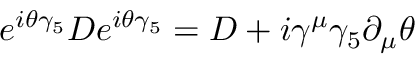Convert formula to latex. <formula><loc_0><loc_0><loc_500><loc_500>e ^ { i \theta \gamma _ { 5 } } D e ^ { i \theta \gamma _ { 5 } } = D + i \gamma ^ { \mu } \gamma _ { 5 } \partial _ { \mu } \theta</formula> 